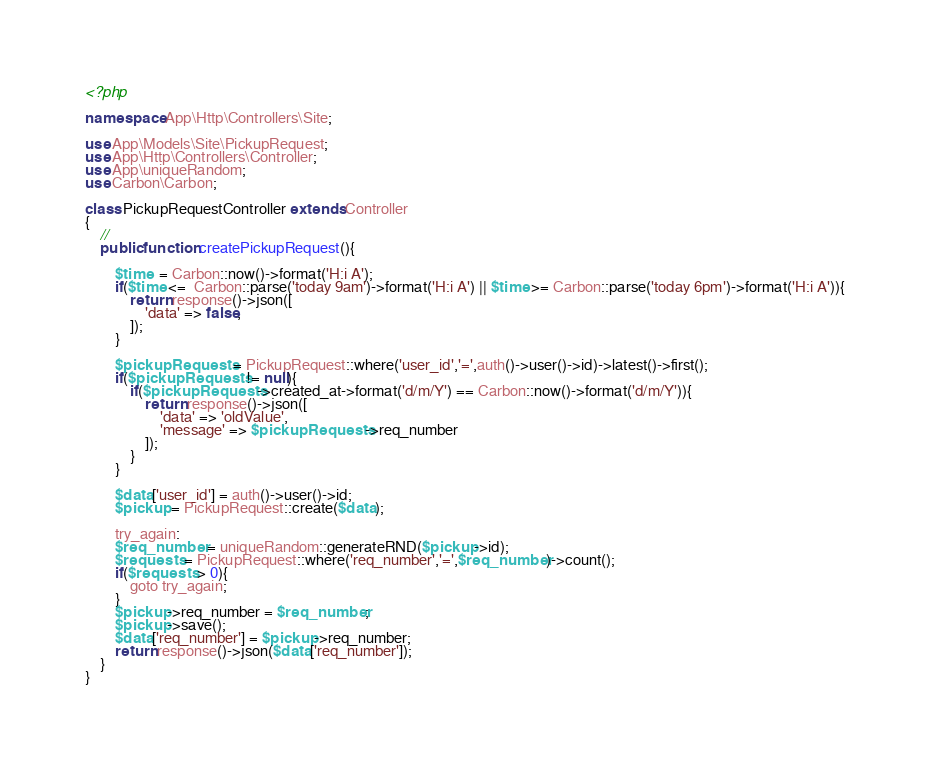Convert code to text. <code><loc_0><loc_0><loc_500><loc_500><_PHP_><?php

namespace App\Http\Controllers\Site;

use App\Models\Site\PickupRequest;
use App\Http\Controllers\Controller;
use App\uniqueRandom;
use Carbon\Carbon;

class PickupRequestController extends Controller
{
    //
    public function createPickupRequest(){

        $time  = Carbon::now()->format('H:i A');
        if($time <=  Carbon::parse('today 9am')->format('H:i A') || $time >= Carbon::parse('today 6pm')->format('H:i A')){
            return response()->json([
                'data' => false,
            ]);
        }

        $pickupRequests = PickupRequest::where('user_id','=',auth()->user()->id)->latest()->first();
        if($pickupRequests != null){
            if($pickupRequests->created_at->format('d/m/Y') == Carbon::now()->format('d/m/Y')){
                return response()->json([
                    'data' => 'oldValue',
                    'message' => $pickupRequests->req_number
                ]);
            }
        }

        $data['user_id'] = auth()->user()->id;
        $pickup = PickupRequest::create($data);

        try_again:
        $req_number = uniqueRandom::generateRND($pickup->id);
        $requests = PickupRequest::where('req_number','=',$req_number)->count();
        if($requests > 0){
            goto try_again;
        }
        $pickup->req_number = $req_number;
        $pickup->save();
        $data['req_number'] = $pickup->req_number;
        return response()->json($data['req_number']);
    }
}
</code> 